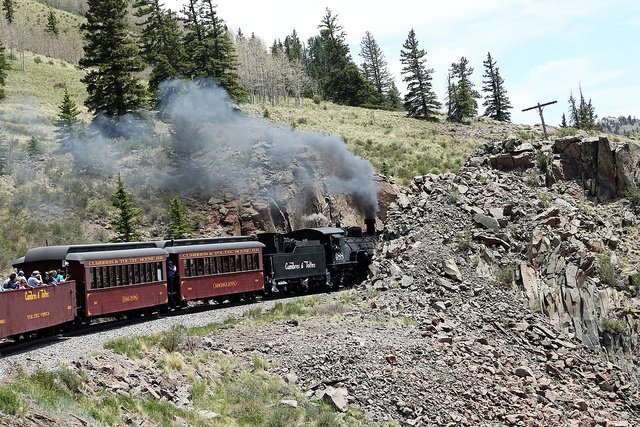Describe the objects in this image and their specific colors. I can see train in tan, black, gray, maroon, and darkgray tones, people in tan, black, navy, gray, and maroon tones, people in tan, gray, lightgray, and black tones, people in tan, black, lightgray, maroon, and darkgray tones, and people in tan, black, navy, gray, and blue tones in this image. 